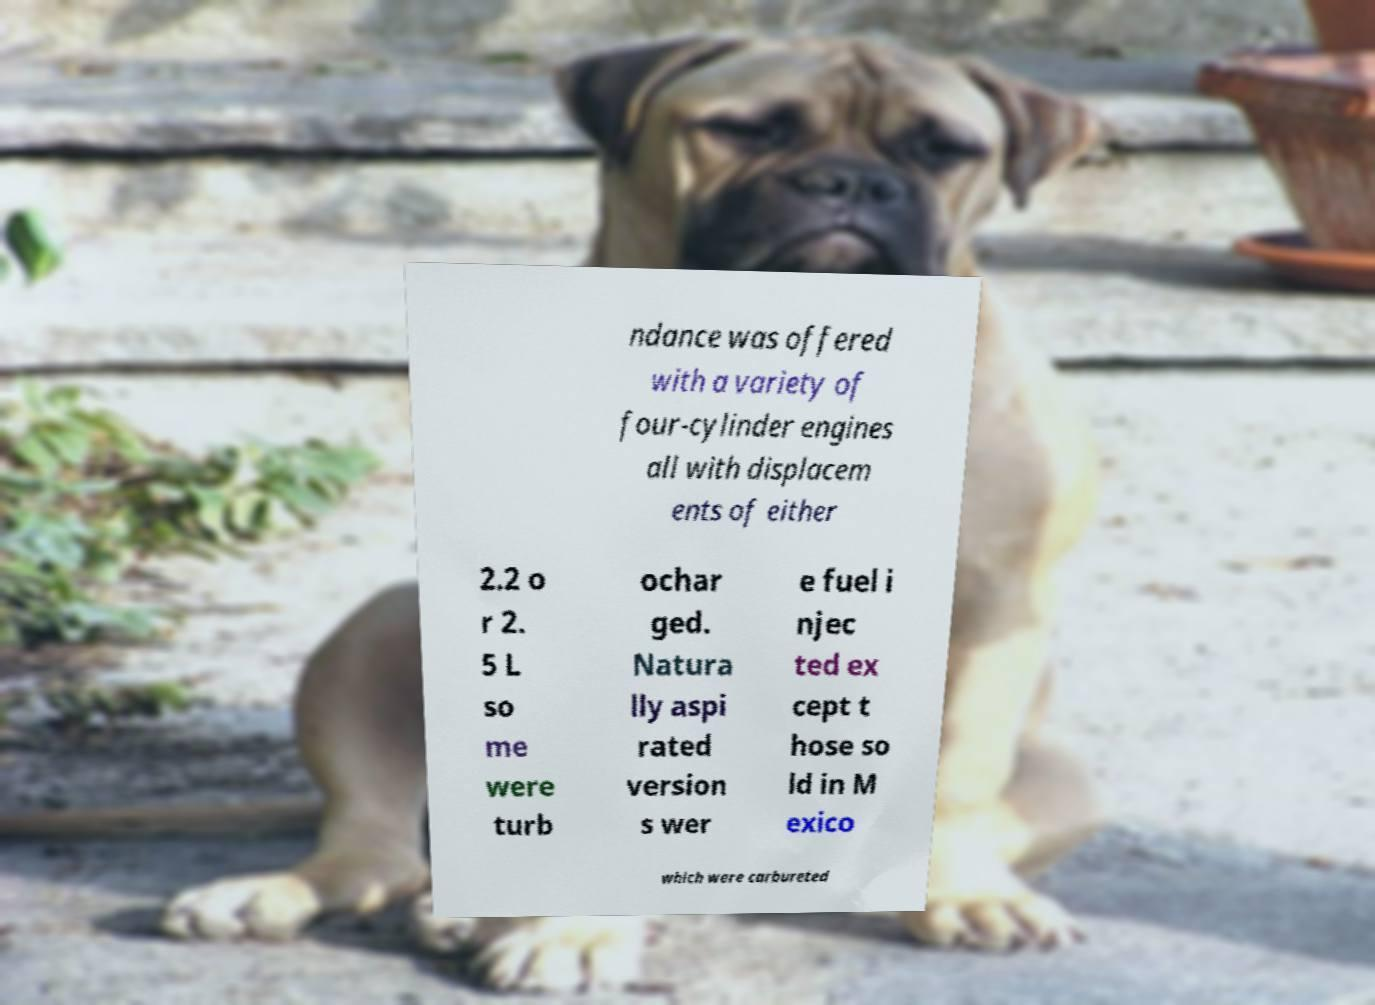I need the written content from this picture converted into text. Can you do that? ndance was offered with a variety of four-cylinder engines all with displacem ents of either 2.2 o r 2. 5 L so me were turb ochar ged. Natura lly aspi rated version s wer e fuel i njec ted ex cept t hose so ld in M exico which were carbureted 